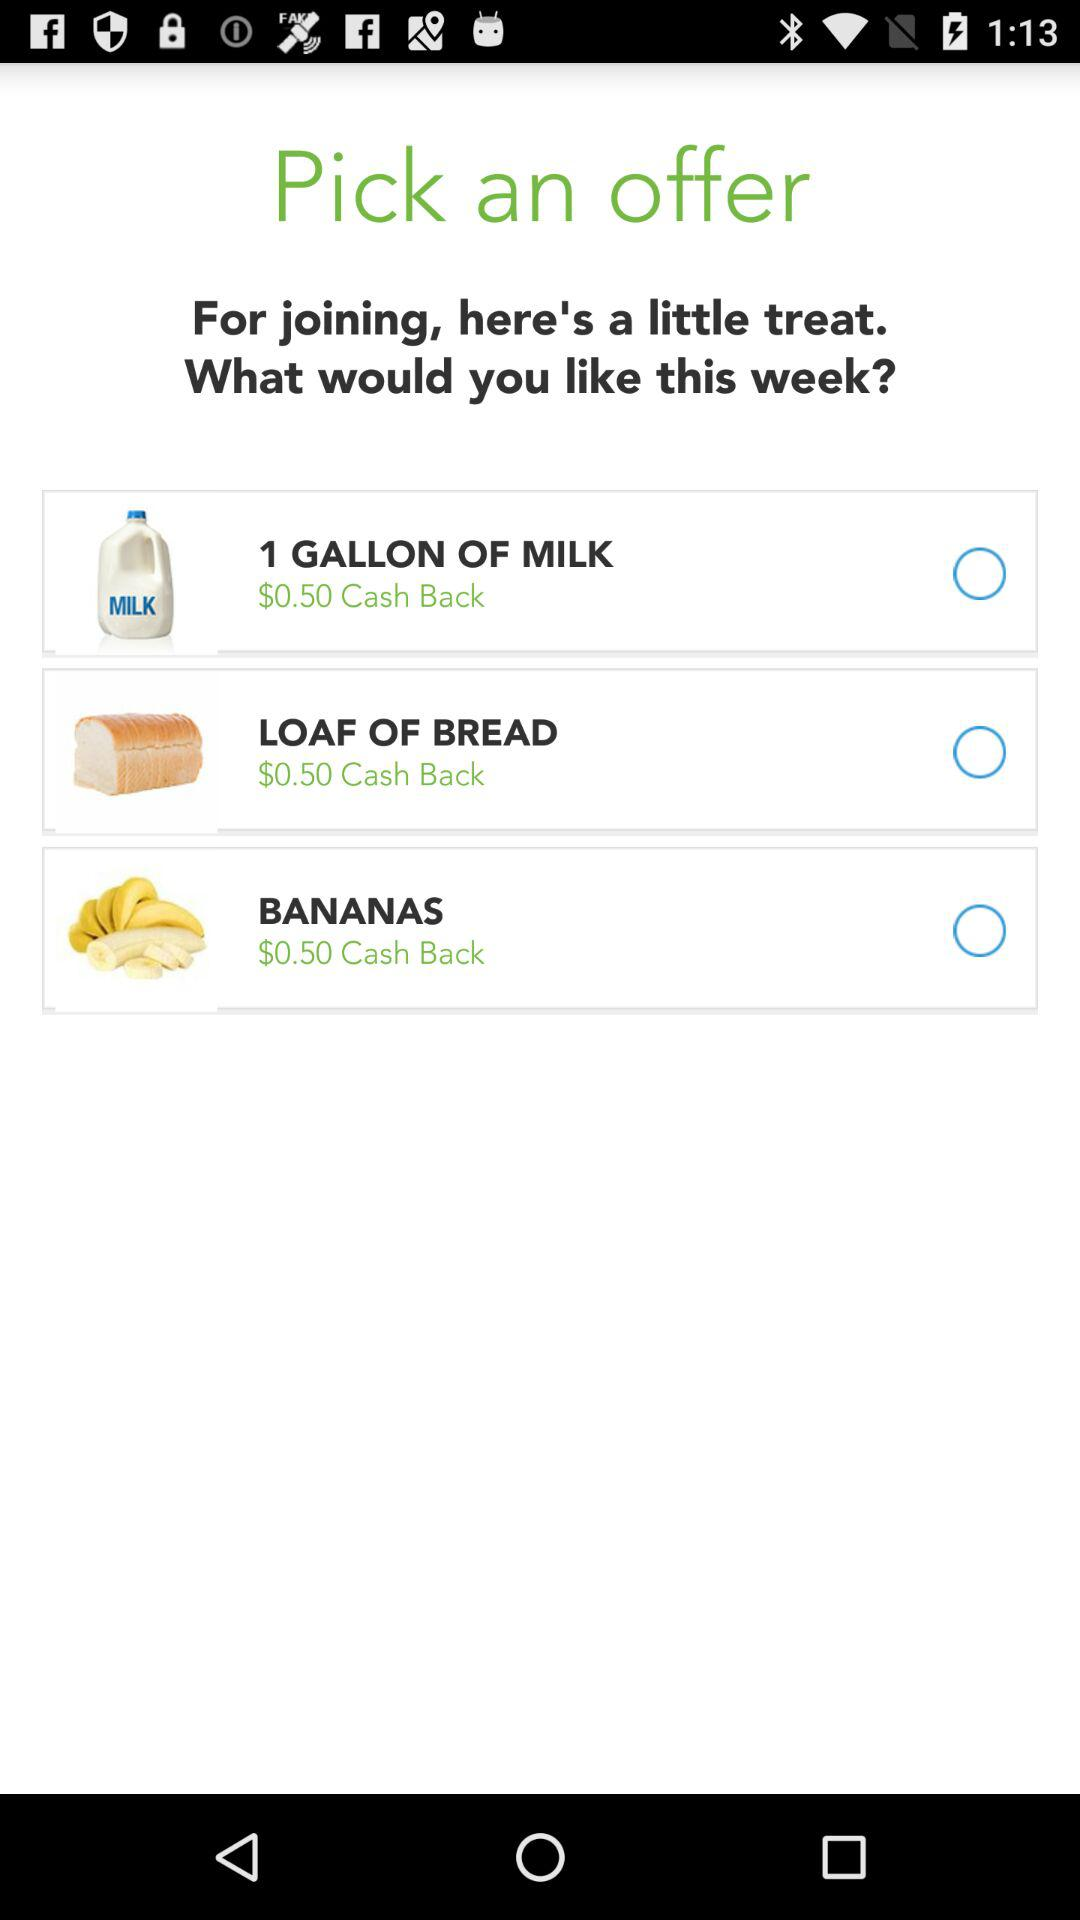How much is the cash back on 1 gallon of milk? The cash back on 1 gallon of milk is $0.50. 